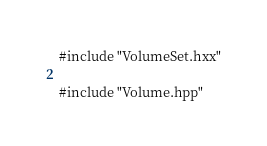Convert code to text. <code><loc_0><loc_0><loc_500><loc_500><_C++_>
#include "VolumeSet.hxx"

#include "Volume.hpp"
</code> 